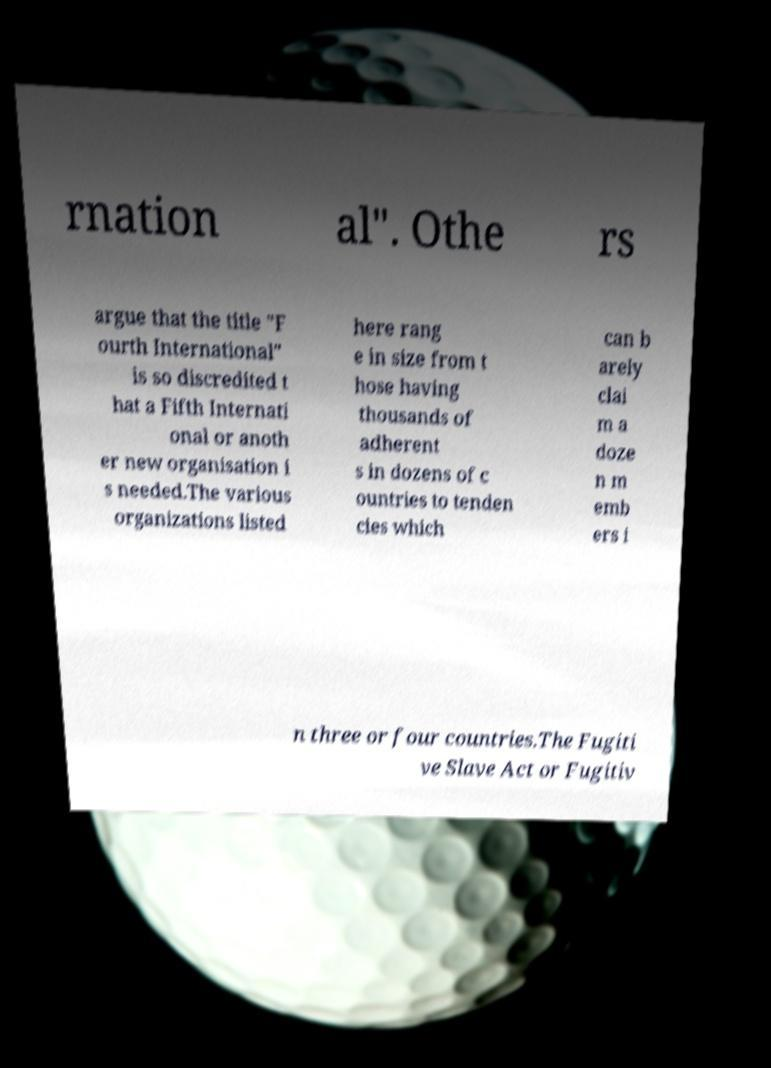For documentation purposes, I need the text within this image transcribed. Could you provide that? rnation al". Othe rs argue that the title "F ourth International" is so discredited t hat a Fifth Internati onal or anoth er new organisation i s needed.The various organizations listed here rang e in size from t hose having thousands of adherent s in dozens of c ountries to tenden cies which can b arely clai m a doze n m emb ers i n three or four countries.The Fugiti ve Slave Act or Fugitiv 